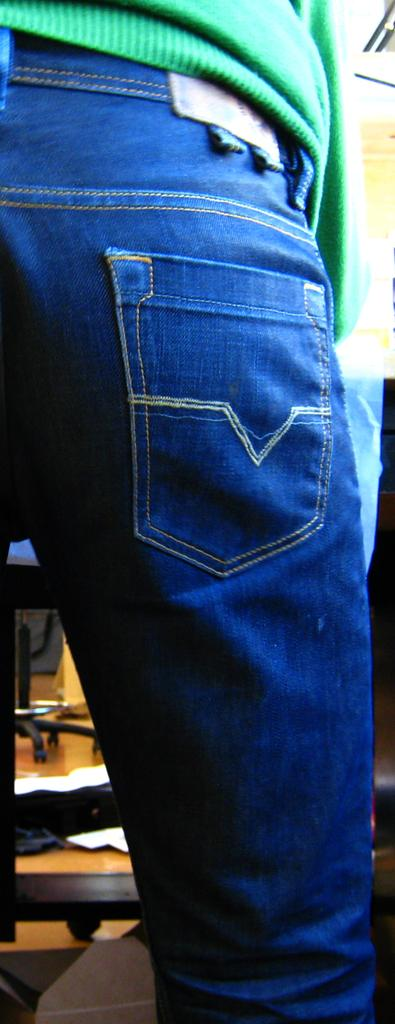What is the person in the image doing? There is a person standing in the image. What is the person wearing? The person is wearing a green sweater and blue jeans. What can be seen in the background of the image? There is a table and chairs in the background of the image. Can you hear the person laughing in the image? There is no sound present in the image, so it is not possible to determine if the person is laughing or not. 